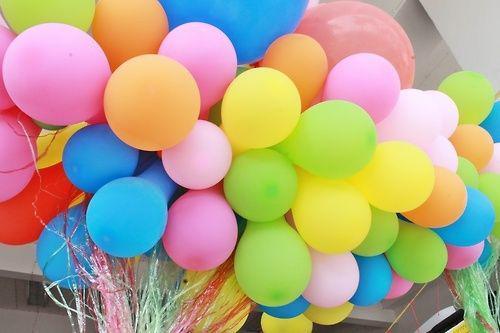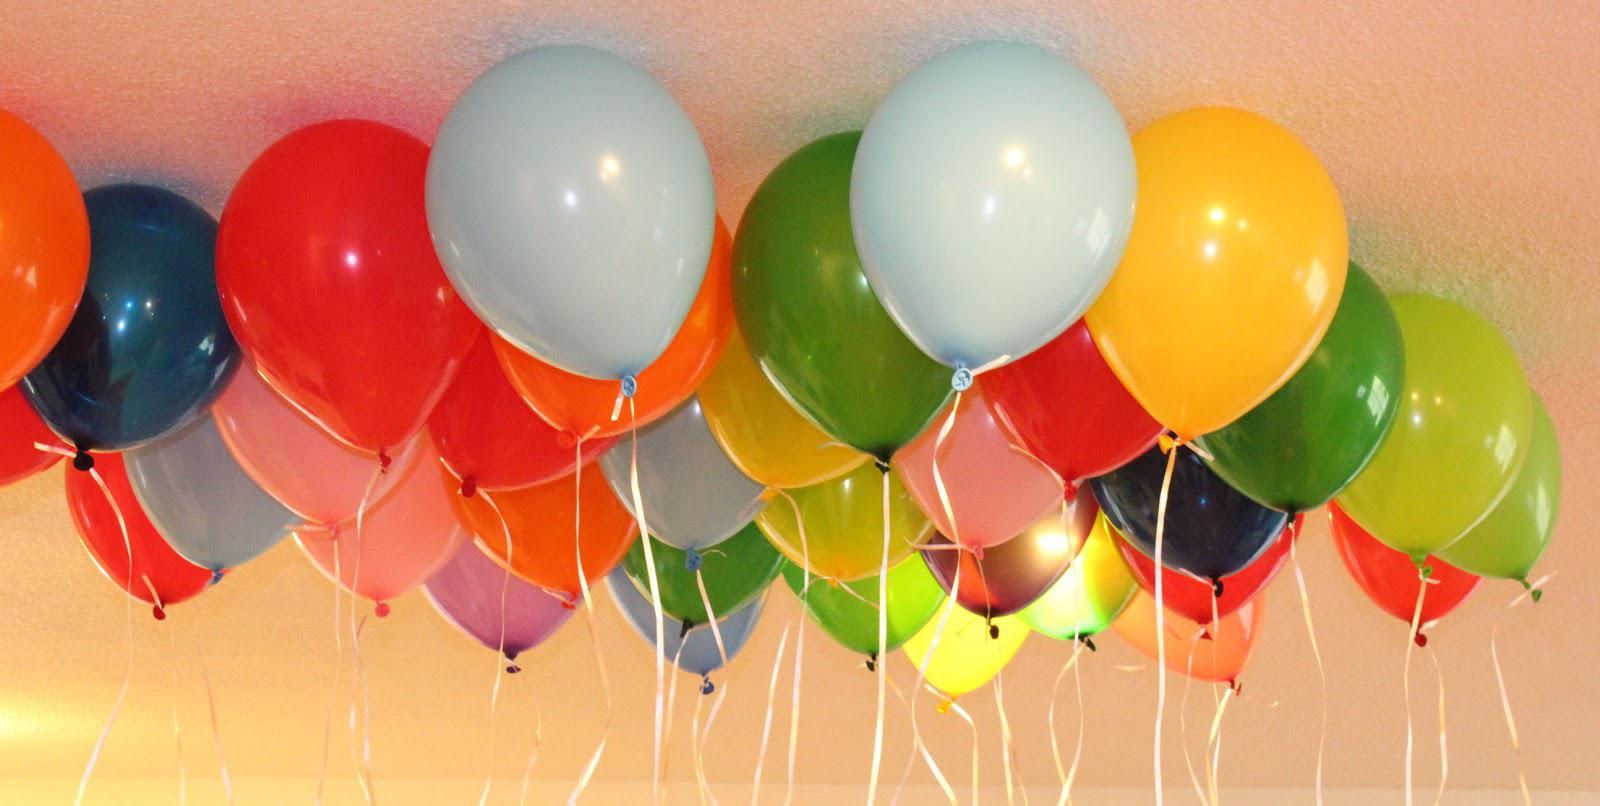The first image is the image on the left, the second image is the image on the right. Analyze the images presented: Is the assertion "in at least one image there are at least fifteen loose balloons on strings." valid? Answer yes or no. Yes. 